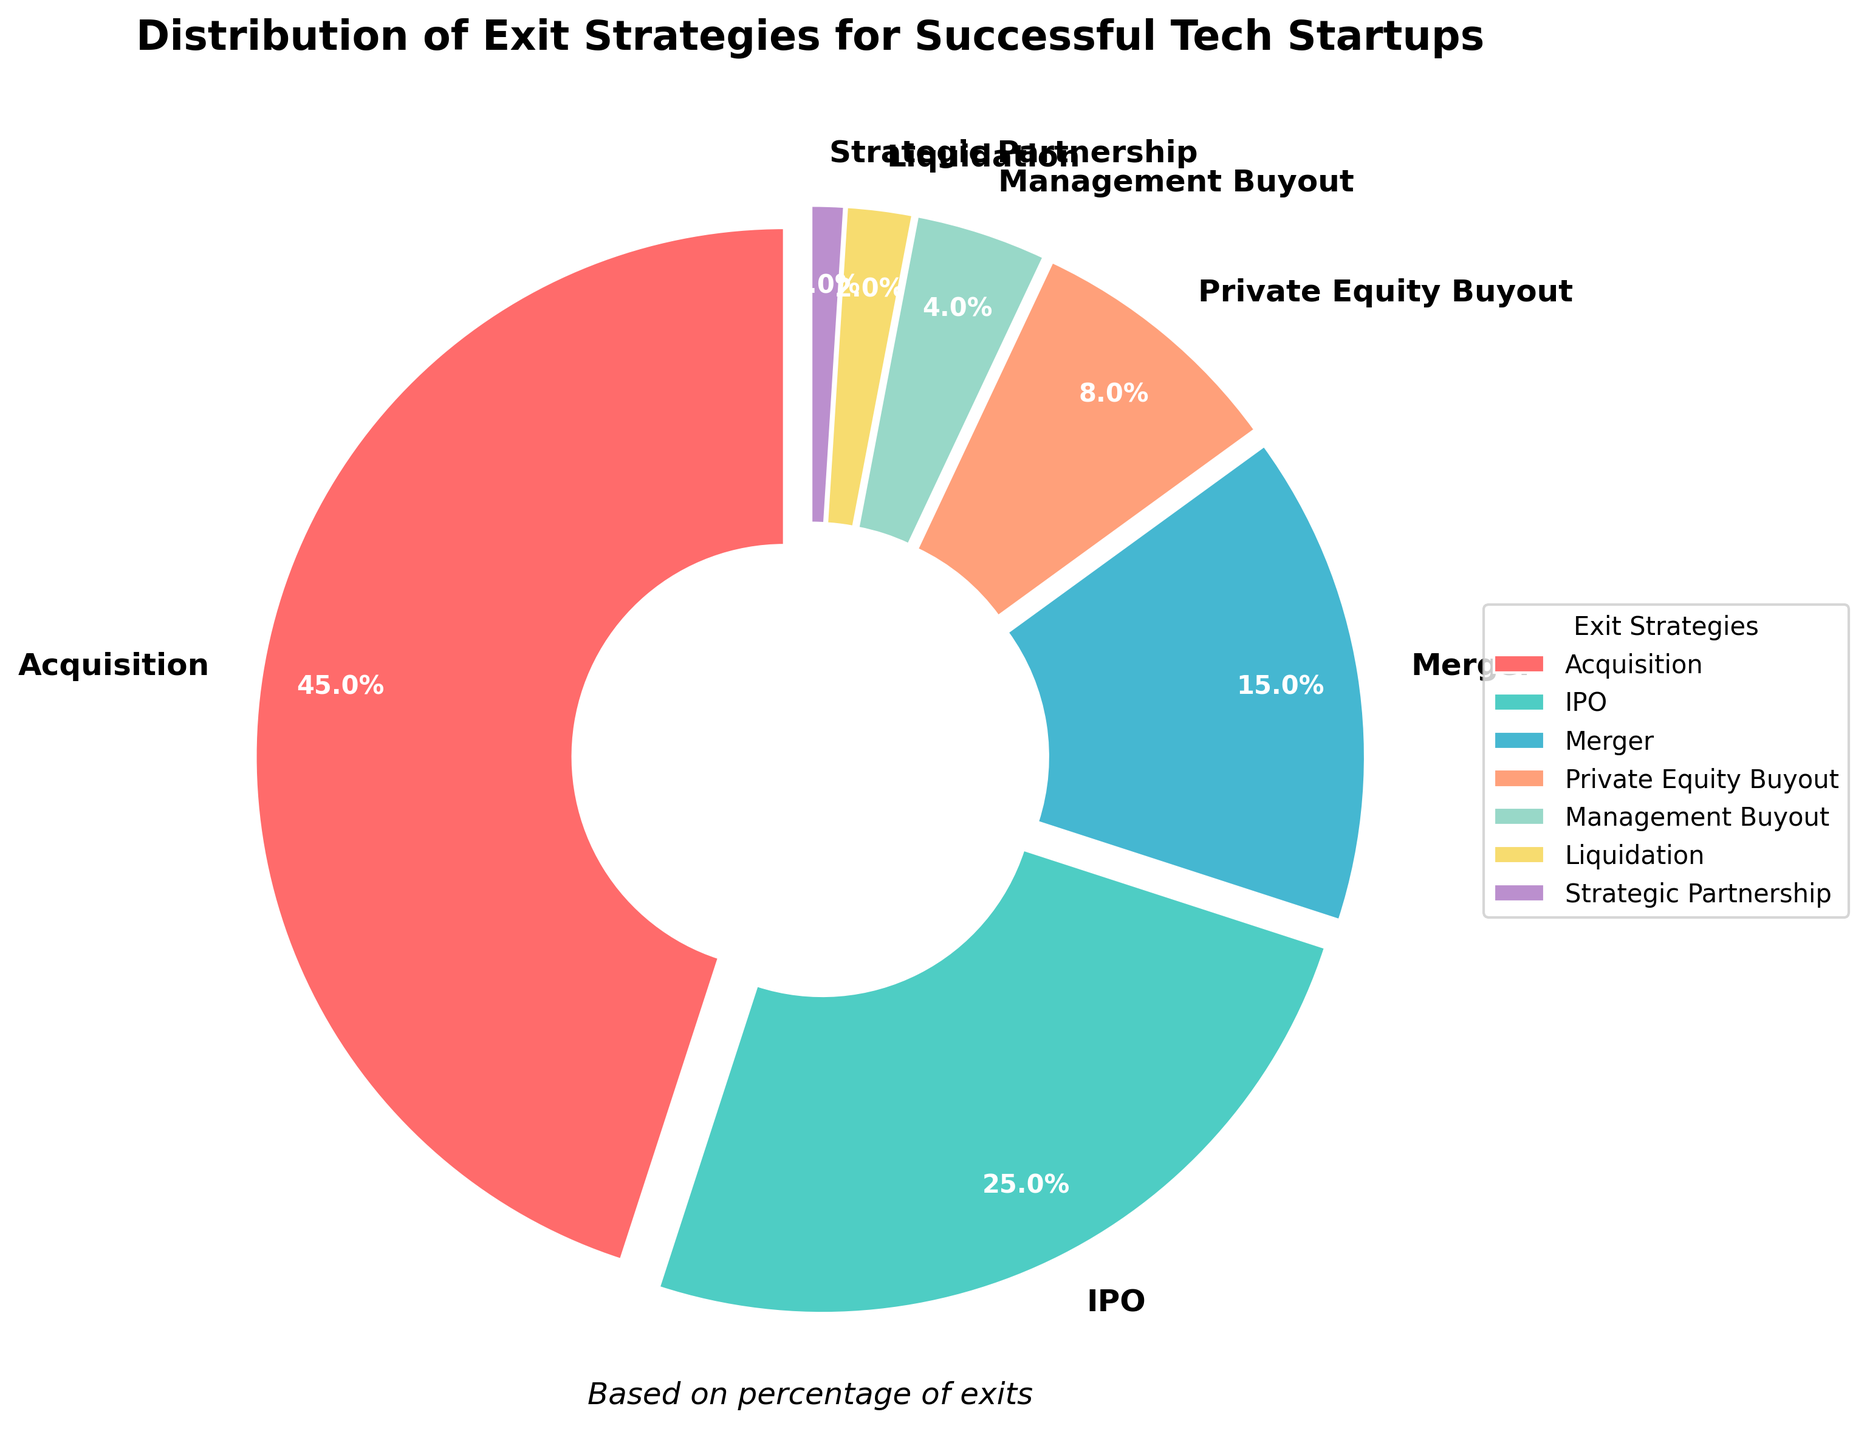What's the most common exit strategy for successful tech startups? The pie chart shows that the largest slice is labeled "Acquisition" with a percentage of 45%, making it the most common exit strategy.
Answer: Acquisition How does the percentage of IPOs compare to mergers? The pie chart indicates that IPOs account for 25% while mergers are 15%. Therefore, IPOs are 10% more common than mergers.
Answer: IPOs are 10% more common What is the combined percentage of Private Equity Buyout and Management Buyout? According to the chart, Private Equity Buyout is 8% and Management Buyout is 4%. Adding these together gives 8% + 4% = 12%.
Answer: 12% Which exit strategy is the least used among the successful tech startups? The smallest slice on the pie chart is labeled "Strategic Partnership," accounting for 1%.
Answer: Strategic Partnership By how much does the percentage of Acquisition exceed the combined percentage of Liquidation and Strategic Partnership? Acquisition is 45%, while Liquidation is 2% and Strategic Partnership is 1%. Combined, these two add up to 3%. The difference is 45% - 3% = 42%.
Answer: 42% What is the second most common exit strategy, and what percentage does it hold? The second largest slice on the pie chart is labeled "IPO" with a percentage of 25%.
Answer: IPO, 25% Compare the total percentage of exit strategies involving buyouts (Private Equity Buyout and Management Buyout) to that of the IPO exit strategy. Which is higher and by how much? Private Equity Buyout is 8% and Management Buyout is 4%, so together they account for 12%. IPO is 25%. The difference is 25% - 12% = 13%, making IPO higher.
Answer: IPO is higher by 13% How does the percentage of mergers compare to the percentage of liquidations and strategic partnerships combined? Mergers are 15%. Liquidation is 2% and Strategic Partnership is 1%, adding together to make 3%. Therefore, mergers exceed them by 12%.
Answer: Mergers exceed by 12% If you were to combine acquisitions, IPOs, and mergers, what percentage of successful tech startup exits would this account for? Acquisitions are 45%, IPOs are 25%, and mergers are 15%. Together, they sum up to 45% + 25% + 15% = 85%.
Answer: 85% 